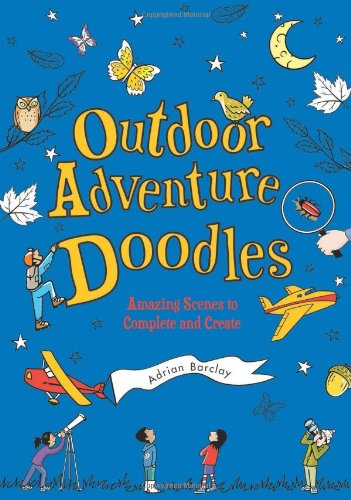What type of book is this? This is a children's activity book designed with a variety of fun and educational doodling exercises that encourage creativity and interaction with outdoor adventure themes. 